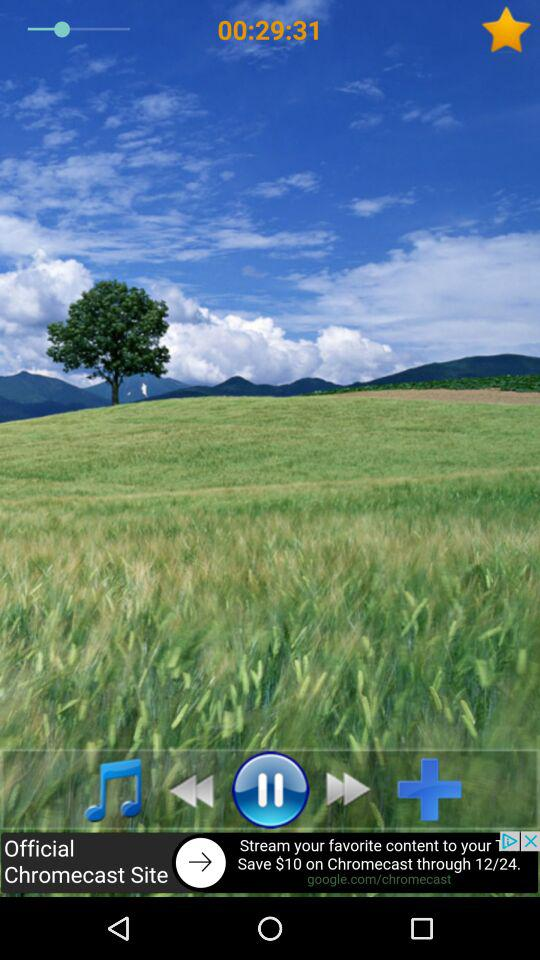What is the duration of the video? The duration of the video is 29 minutes 31 seconds. 